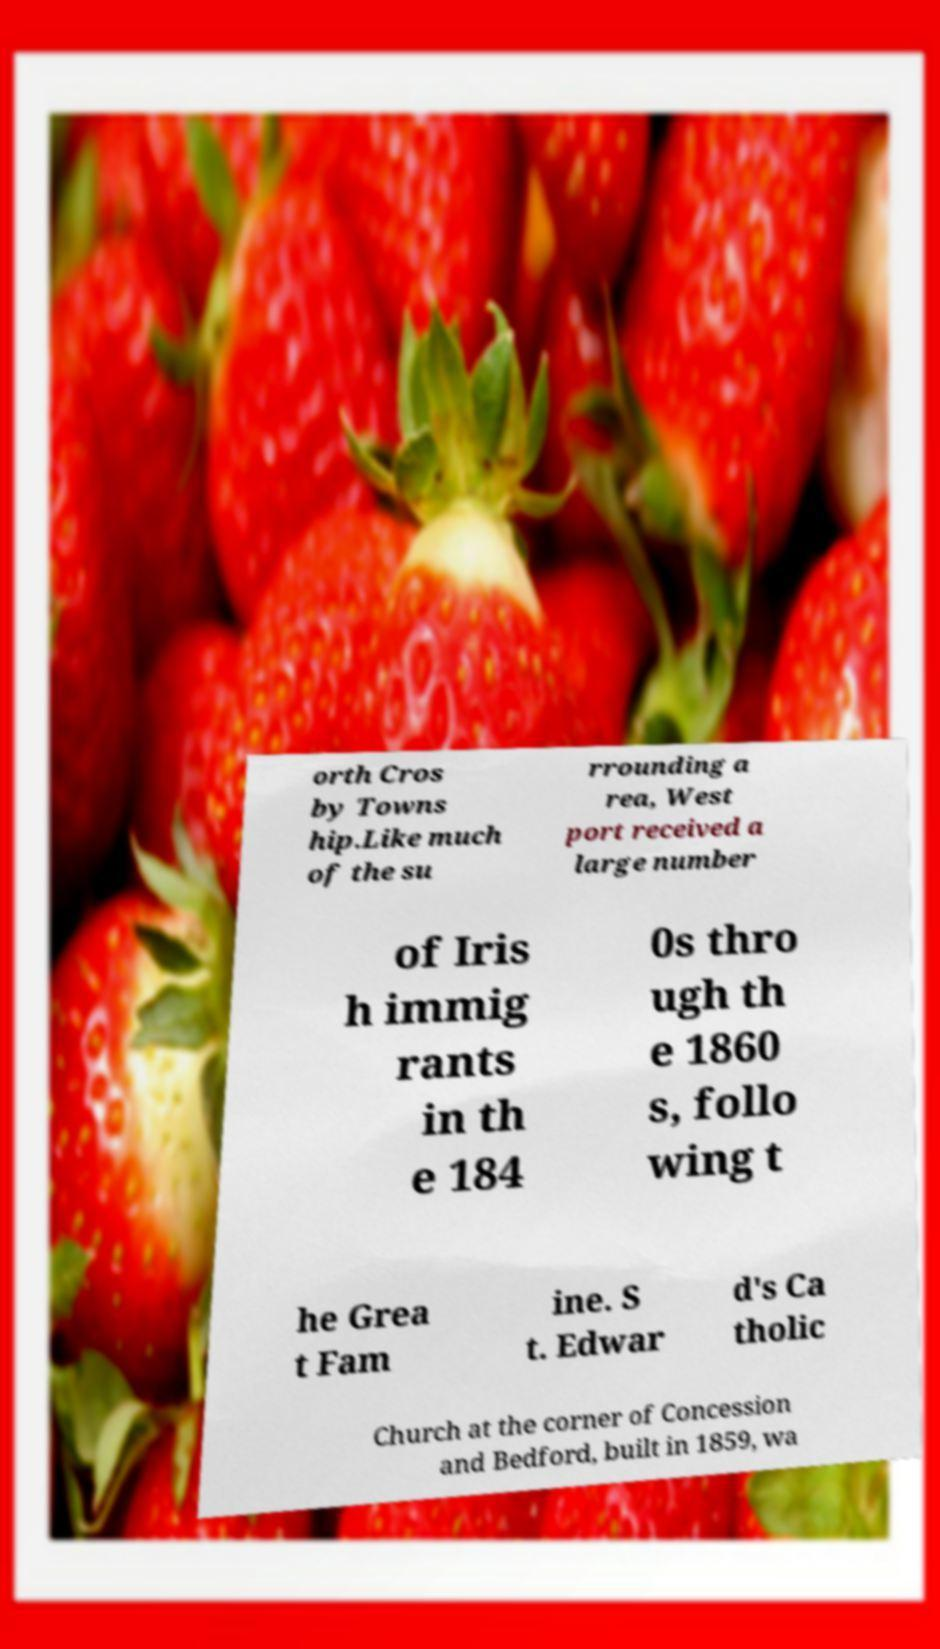Can you accurately transcribe the text from the provided image for me? orth Cros by Towns hip.Like much of the su rrounding a rea, West port received a large number of Iris h immig rants in th e 184 0s thro ugh th e 1860 s, follo wing t he Grea t Fam ine. S t. Edwar d's Ca tholic Church at the corner of Concession and Bedford, built in 1859, wa 